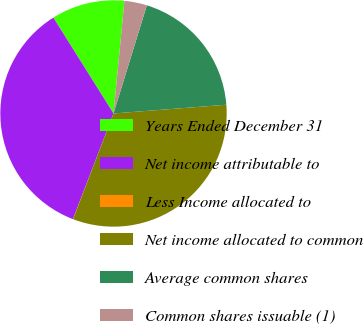Convert chart. <chart><loc_0><loc_0><loc_500><loc_500><pie_chart><fcel>Years Ended December 31<fcel>Net income attributable to<fcel>Less Income allocated to<fcel>Net income allocated to common<fcel>Average common shares<fcel>Common shares issuable (1)<nl><fcel>10.46%<fcel>35.25%<fcel>0.02%<fcel>32.05%<fcel>19.01%<fcel>3.22%<nl></chart> 